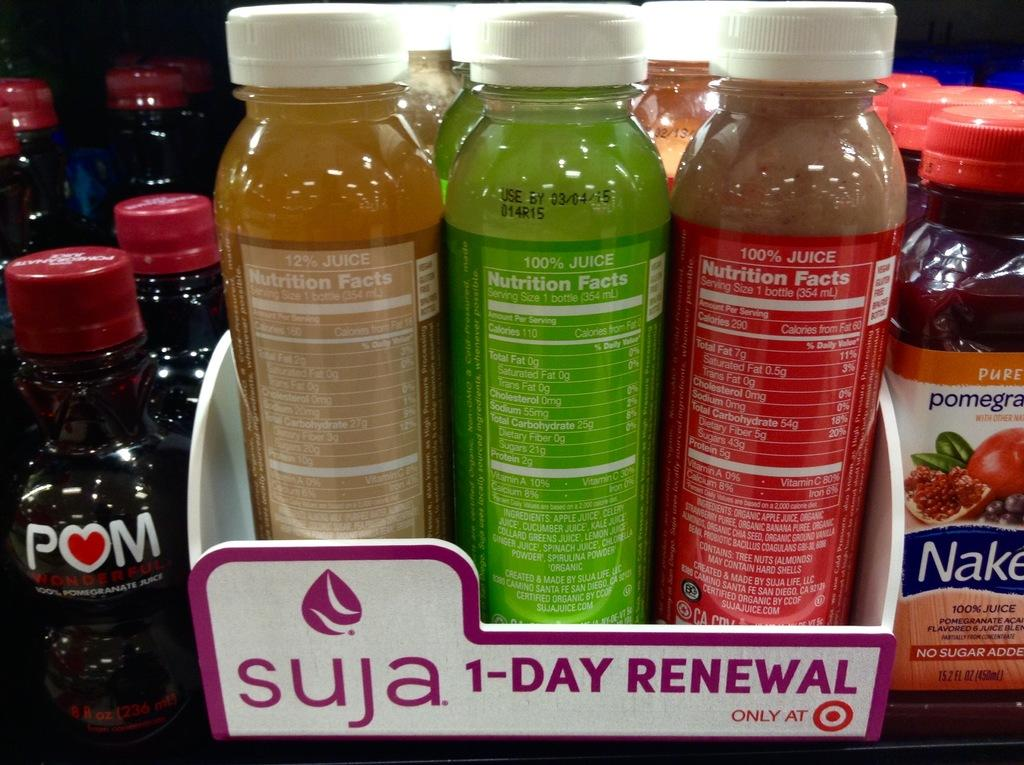<image>
Create a compact narrative representing the image presented. The water in the box is by the company Suja. 